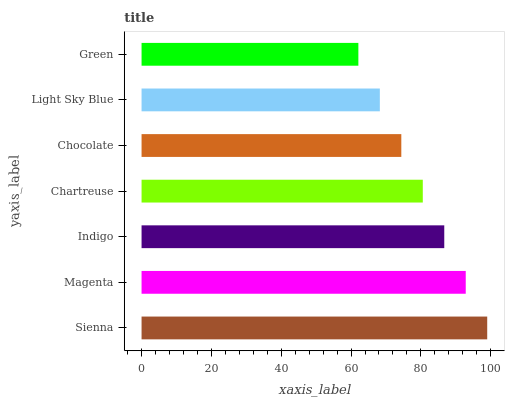Is Green the minimum?
Answer yes or no. Yes. Is Sienna the maximum?
Answer yes or no. Yes. Is Magenta the minimum?
Answer yes or no. No. Is Magenta the maximum?
Answer yes or no. No. Is Sienna greater than Magenta?
Answer yes or no. Yes. Is Magenta less than Sienna?
Answer yes or no. Yes. Is Magenta greater than Sienna?
Answer yes or no. No. Is Sienna less than Magenta?
Answer yes or no. No. Is Chartreuse the high median?
Answer yes or no. Yes. Is Chartreuse the low median?
Answer yes or no. Yes. Is Chocolate the high median?
Answer yes or no. No. Is Light Sky Blue the low median?
Answer yes or no. No. 